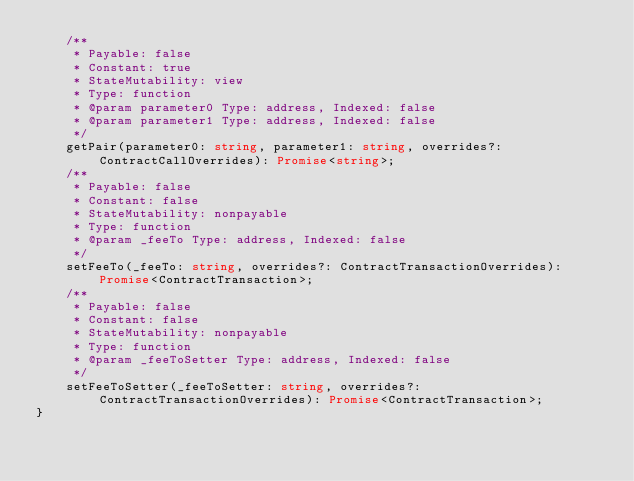Convert code to text. <code><loc_0><loc_0><loc_500><loc_500><_TypeScript_>    /**
     * Payable: false
     * Constant: true
     * StateMutability: view
     * Type: function
     * @param parameter0 Type: address, Indexed: false
     * @param parameter1 Type: address, Indexed: false
     */
    getPair(parameter0: string, parameter1: string, overrides?: ContractCallOverrides): Promise<string>;
    /**
     * Payable: false
     * Constant: false
     * StateMutability: nonpayable
     * Type: function
     * @param _feeTo Type: address, Indexed: false
     */
    setFeeTo(_feeTo: string, overrides?: ContractTransactionOverrides): Promise<ContractTransaction>;
    /**
     * Payable: false
     * Constant: false
     * StateMutability: nonpayable
     * Type: function
     * @param _feeToSetter Type: address, Indexed: false
     */
    setFeeToSetter(_feeToSetter: string, overrides?: ContractTransactionOverrides): Promise<ContractTransaction>;
}
</code> 